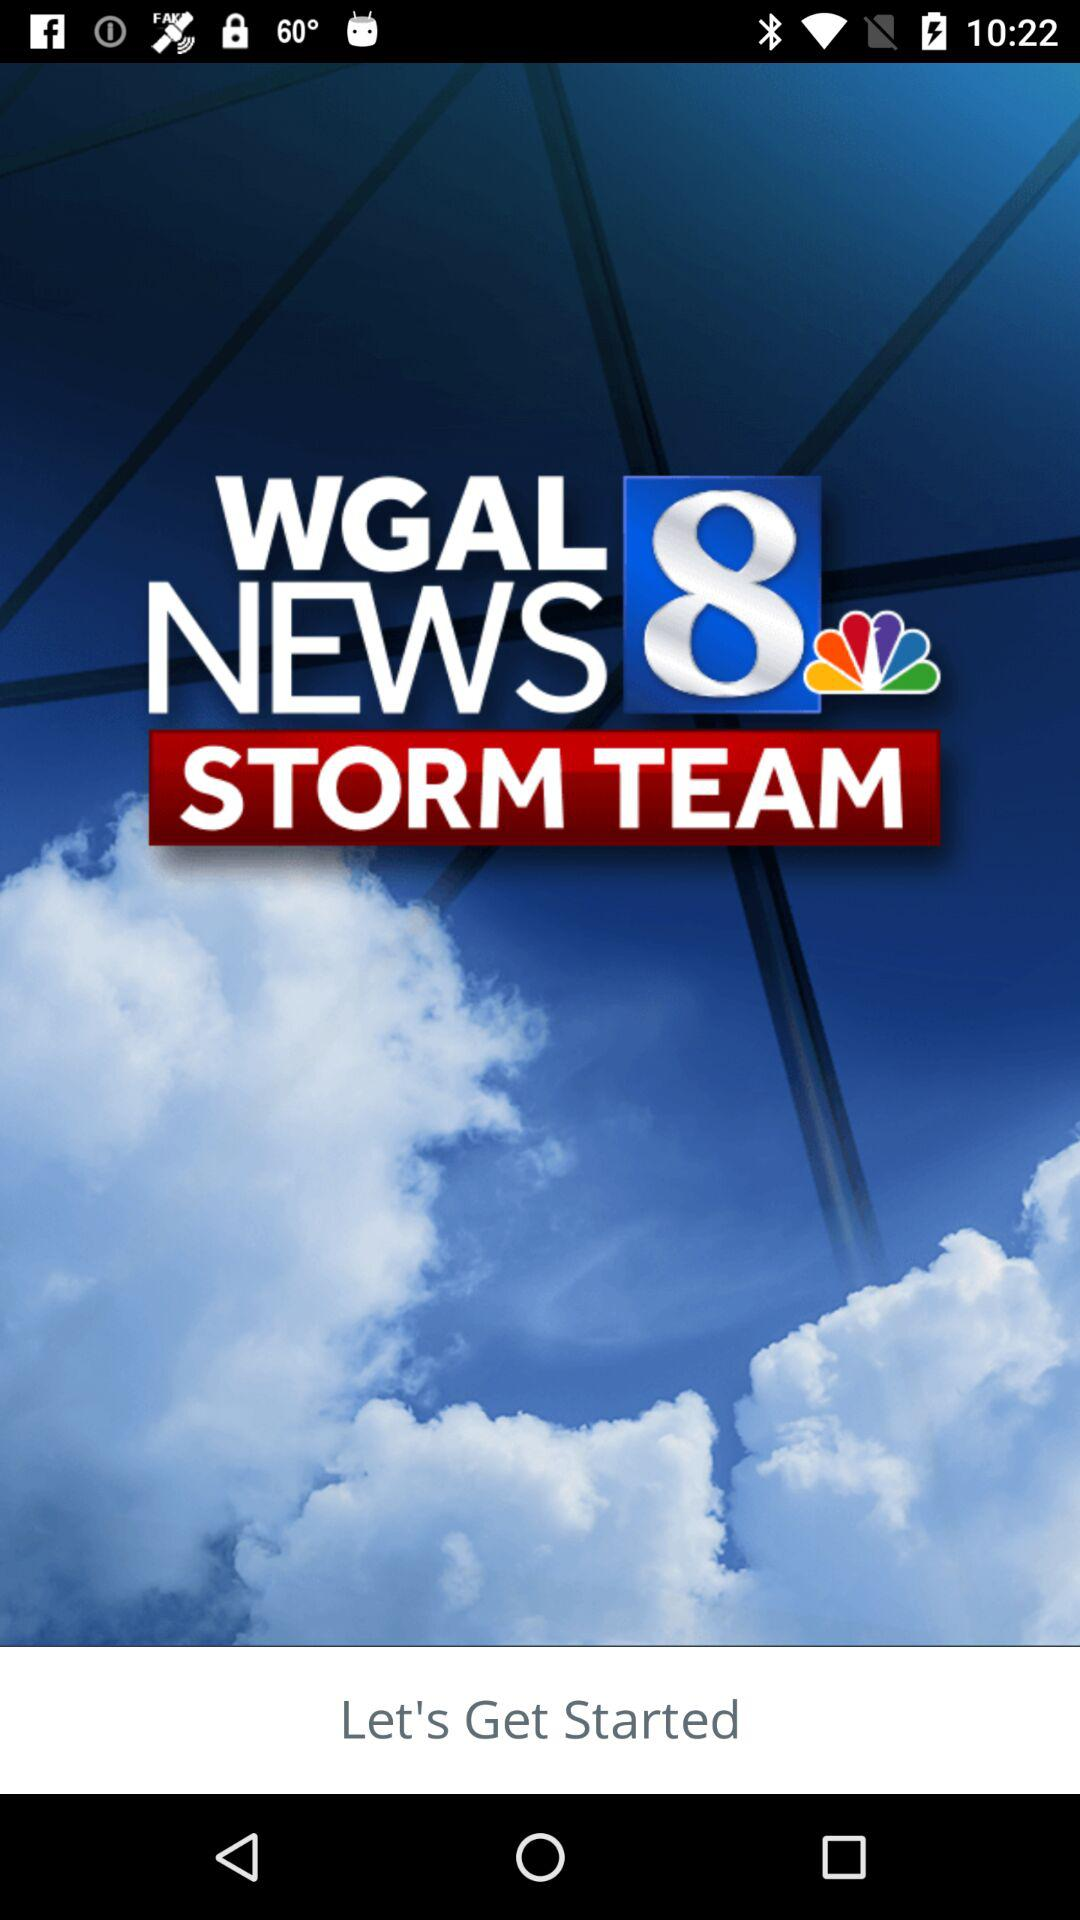What is the name of the application? The name of the application is "WGAL NEWS 8 STORM TEAM". 